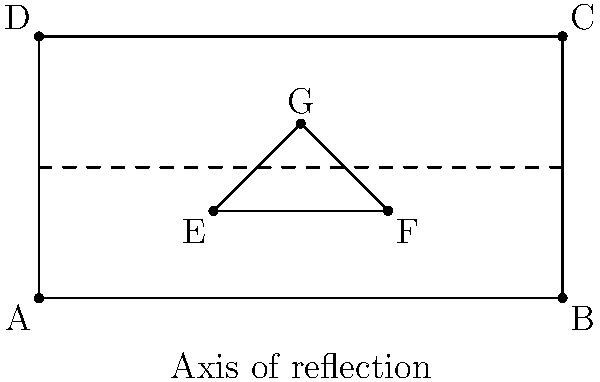At Matthew Sweet's upcoming concert, the stage manager wants to create a symmetrical setup. The triangle EFG represents a group of speakers on one side of the stage. If this triangle is reflected across the dashed line (axis of reflection) to create a mirror image on the other side of the stage, what will be the coordinates of point G' (the reflection of point G)? To find the coordinates of G' (the reflection of point G), we need to follow these steps:

1) First, identify the coordinates of point G: G(0,2)

2) The axis of reflection is the horizontal line y = 1.5

3) To reflect a point across a horizontal line, we keep the x-coordinate the same and calculate the new y-coordinate using the formula:
   
   $y' = 2k - y$
   
   where k is the y-coordinate of the axis of reflection, y is the original y-coordinate, and y' is the new y-coordinate.

4) In this case:
   $k = 1.5$ (y-coordinate of the axis of reflection)
   $y = 2$ (y-coordinate of point G)

5) Plugging these values into the formula:
   $y' = 2(1.5) - 2 = 3 - 2 = 1$

6) The x-coordinate remains the same: x' = 0

Therefore, the coordinates of G' will be (0,1).
Answer: (0,1) 